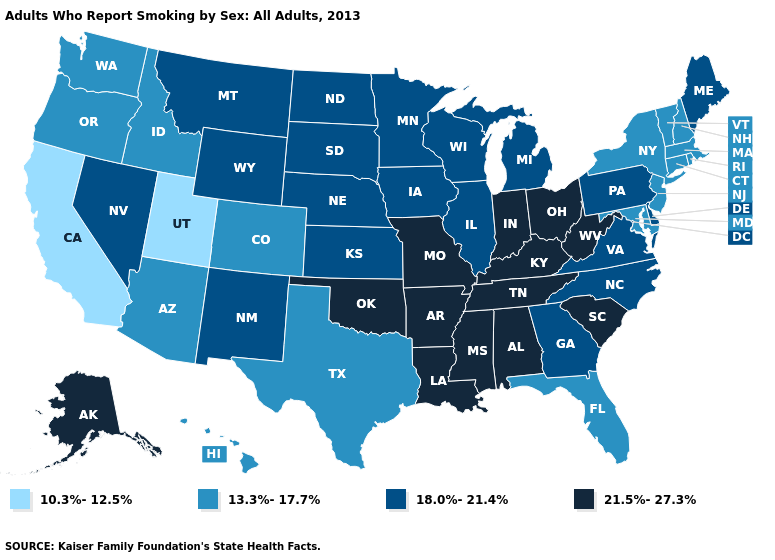Among the states that border Vermont , which have the lowest value?
Answer briefly. Massachusetts, New Hampshire, New York. What is the lowest value in states that border Idaho?
Answer briefly. 10.3%-12.5%. Does the map have missing data?
Keep it brief. No. Among the states that border Missouri , which have the highest value?
Short answer required. Arkansas, Kentucky, Oklahoma, Tennessee. What is the highest value in the USA?
Concise answer only. 21.5%-27.3%. Does the first symbol in the legend represent the smallest category?
Be succinct. Yes. Among the states that border North Carolina , which have the highest value?
Give a very brief answer. South Carolina, Tennessee. Name the states that have a value in the range 21.5%-27.3%?
Give a very brief answer. Alabama, Alaska, Arkansas, Indiana, Kentucky, Louisiana, Mississippi, Missouri, Ohio, Oklahoma, South Carolina, Tennessee, West Virginia. What is the highest value in the USA?
Give a very brief answer. 21.5%-27.3%. Is the legend a continuous bar?
Concise answer only. No. What is the value of Florida?
Keep it brief. 13.3%-17.7%. Does Mississippi have the highest value in the South?
Give a very brief answer. Yes. What is the value of Nevada?
Quick response, please. 18.0%-21.4%. What is the value of Delaware?
Be succinct. 18.0%-21.4%. Name the states that have a value in the range 21.5%-27.3%?
Be succinct. Alabama, Alaska, Arkansas, Indiana, Kentucky, Louisiana, Mississippi, Missouri, Ohio, Oklahoma, South Carolina, Tennessee, West Virginia. 